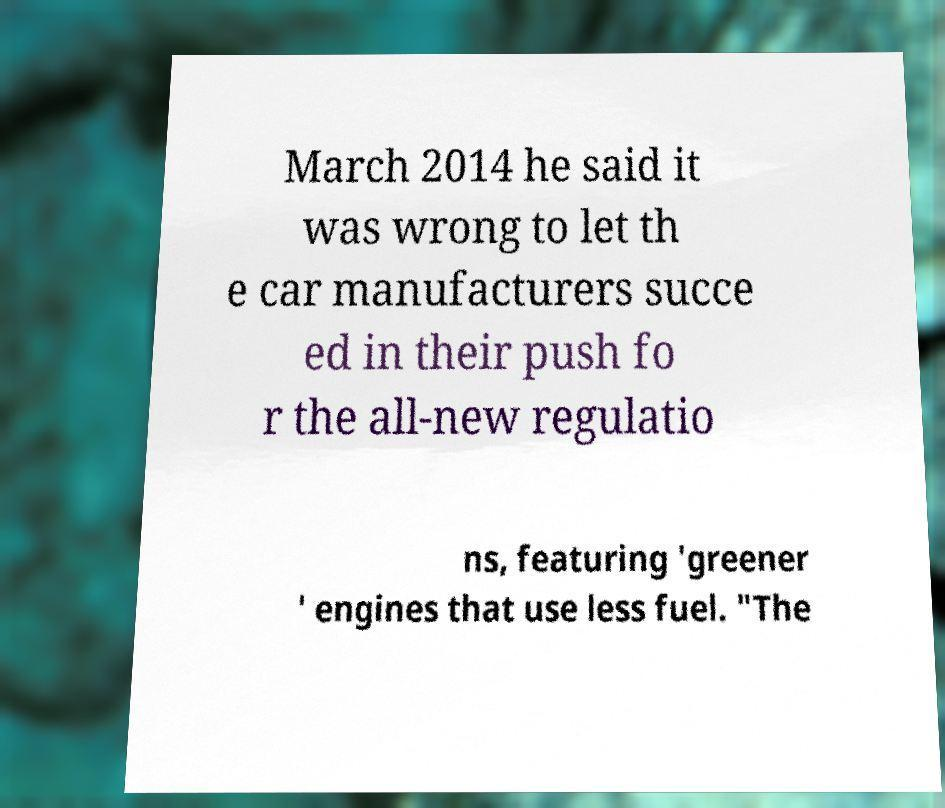Can you read and provide the text displayed in the image?This photo seems to have some interesting text. Can you extract and type it out for me? March 2014 he said it was wrong to let th e car manufacturers succe ed in their push fo r the all-new regulatio ns, featuring 'greener ' engines that use less fuel. "The 